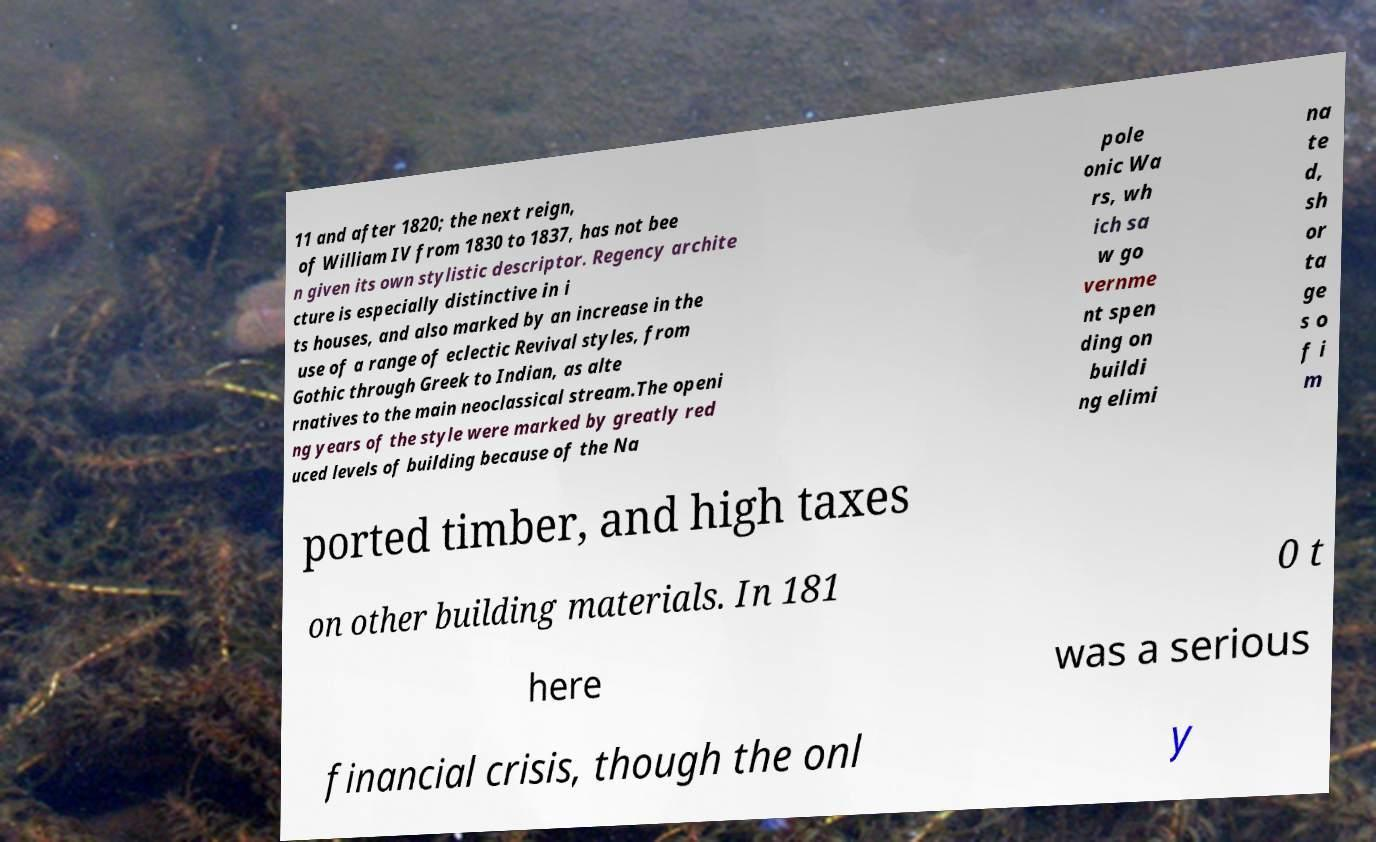Can you accurately transcribe the text from the provided image for me? 11 and after 1820; the next reign, of William IV from 1830 to 1837, has not bee n given its own stylistic descriptor. Regency archite cture is especially distinctive in i ts houses, and also marked by an increase in the use of a range of eclectic Revival styles, from Gothic through Greek to Indian, as alte rnatives to the main neoclassical stream.The openi ng years of the style were marked by greatly red uced levels of building because of the Na pole onic Wa rs, wh ich sa w go vernme nt spen ding on buildi ng elimi na te d, sh or ta ge s o f i m ported timber, and high taxes on other building materials. In 181 0 t here was a serious financial crisis, though the onl y 